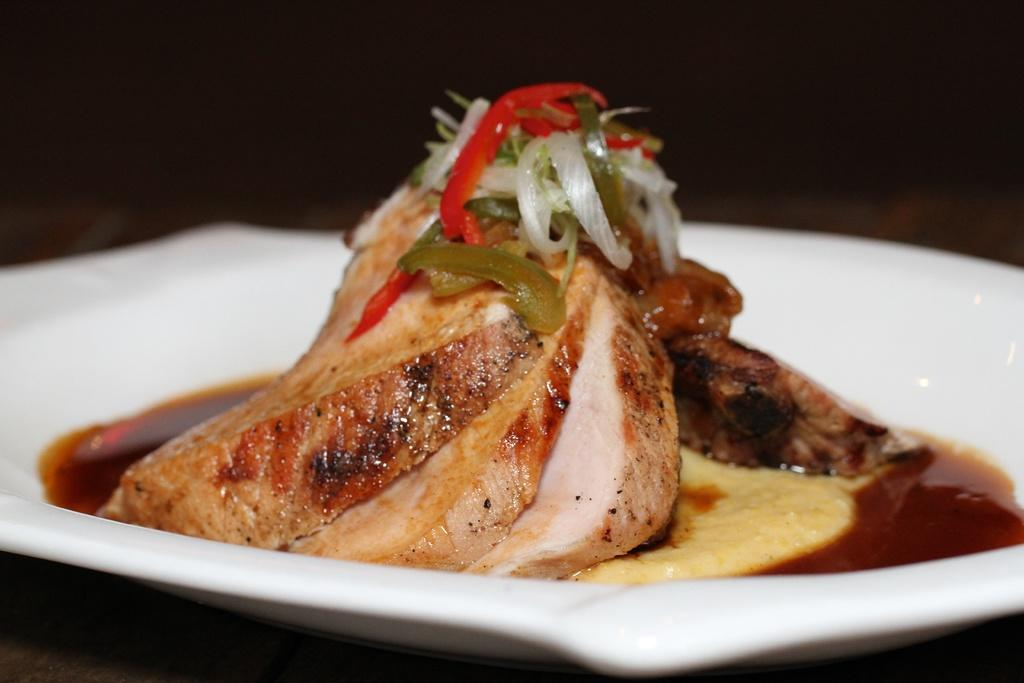What is on the plate in the image? There is food on a white plate in the image. What can be seen in the background of the image? The background of the image is dark. How many beds are visible in the image? There are no beds present in the image. What type of class is being held in the image? There is no class being held in the image. 